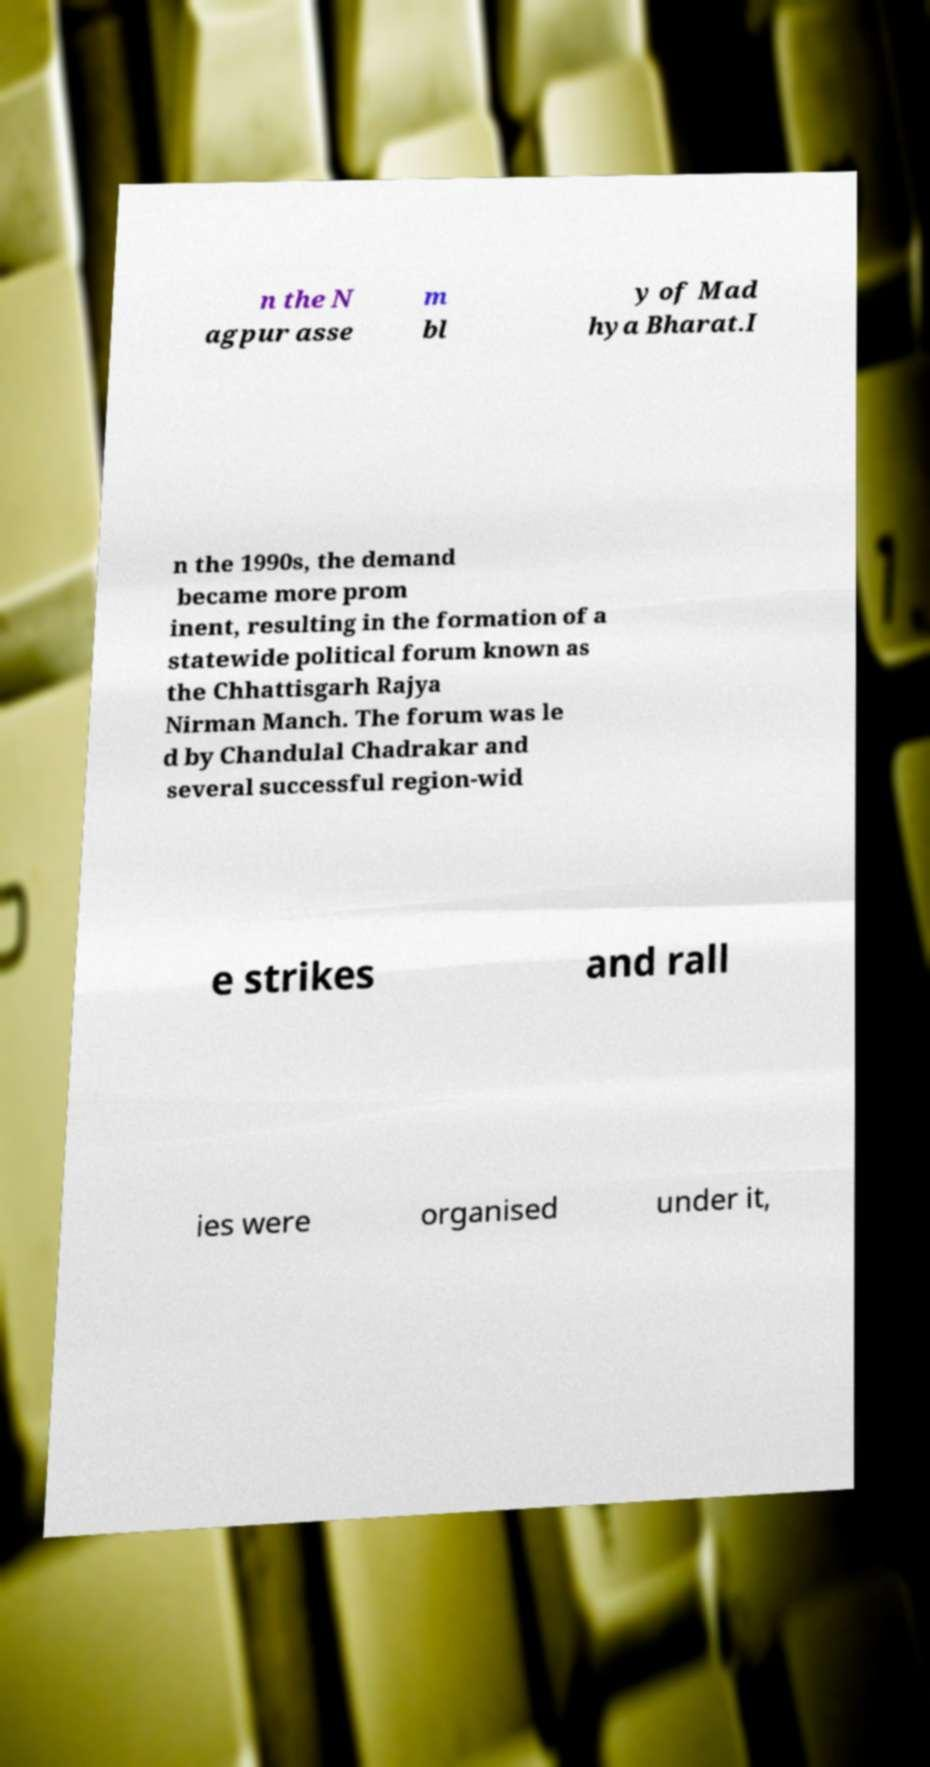Can you read and provide the text displayed in the image?This photo seems to have some interesting text. Can you extract and type it out for me? n the N agpur asse m bl y of Mad hya Bharat.I n the 1990s, the demand became more prom inent, resulting in the formation of a statewide political forum known as the Chhattisgarh Rajya Nirman Manch. The forum was le d by Chandulal Chadrakar and several successful region-wid e strikes and rall ies were organised under it, 